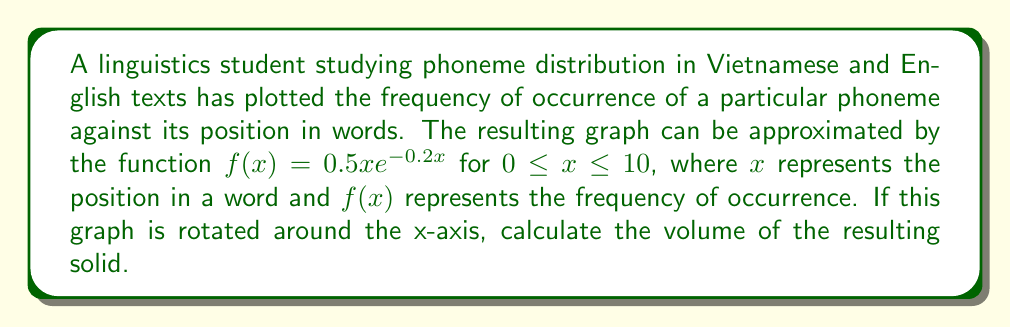Can you solve this math problem? To solve this problem, we need to use the formula for the volume of a solid of revolution around the x-axis:

$$V = \pi \int_a^b [f(x)]^2 dx$$

Where $a$ and $b$ are the limits of integration.

Given:
- $f(x) = 0.5x e^{-0.2x}$
- Limits: $0 \leq x \leq 10$

Steps:
1) Substitute the function into the volume formula:
   $$V = \pi \int_0^{10} (0.5x e^{-0.2x})^2 dx$$

2) Simplify the integrand:
   $$V = \pi \int_0^{10} 0.25x^2 e^{-0.4x} dx$$

3) This integral is not easily solvable by basic integration techniques. We need to use integration by parts twice.

   Let $u = x^2$ and $dv = e^{-0.4x} dx$
   Then $du = 2x dx$ and $v = -\frac{1}{0.4} e^{-0.4x}$

   First application of integration by parts:
   $$\int x^2 e^{-0.4x} dx = -\frac{1}{0.4} x^2 e^{-0.4x} + \frac{2}{0.4} \int x e^{-0.4x} dx$$

   For the remaining integral, let $u = x$ and $dv = e^{-0.4x} dx$
   Then $du = dx$ and $v = -\frac{1}{0.4} e^{-0.4x}$

   Second application of integration by parts:
   $$\int x e^{-0.4x} dx = -\frac{1}{0.4} x e^{-0.4x} - \frac{1}{0.4} \int e^{-0.4x} dx$$

   $$= -\frac{1}{0.4} x e^{-0.4x} + \frac{1}{0.16} e^{-0.4x}$$

4) Combining the results:
   $$\int x^2 e^{-0.4x} dx = -\frac{1}{0.4} x^2 e^{-0.4x} + \frac{2}{0.4} (-\frac{1}{0.4} x e^{-0.4x} + \frac{1}{0.16} e^{-0.4x}) + C$$

   $$= (-\frac{1}{0.4} x^2 - \frac{5}{0.4^2} x - \frac{25}{0.4^3}) e^{-0.4x} + C$$

5) Apply the limits and multiply by $0.25\pi$:
   $$V = 0.25\pi [(-\frac{1}{0.4} x^2 - \frac{5}{0.4^2} x - \frac{25}{0.4^3}) e^{-0.4x}]_0^{10}$$

6) Evaluate:
   $$V = 0.25\pi [(-62.5 - 312.5 - 1562.5) e^{-4} - (-0 - 0 - 1562.5)]$$
   $$= 0.25\pi [-1937.5 e^{-4} + 1562.5]$$
   $$\approx 307.31$$
Answer: The volume of the solid formed by rotating the graph around the x-axis is approximately 307.31 cubic units. 